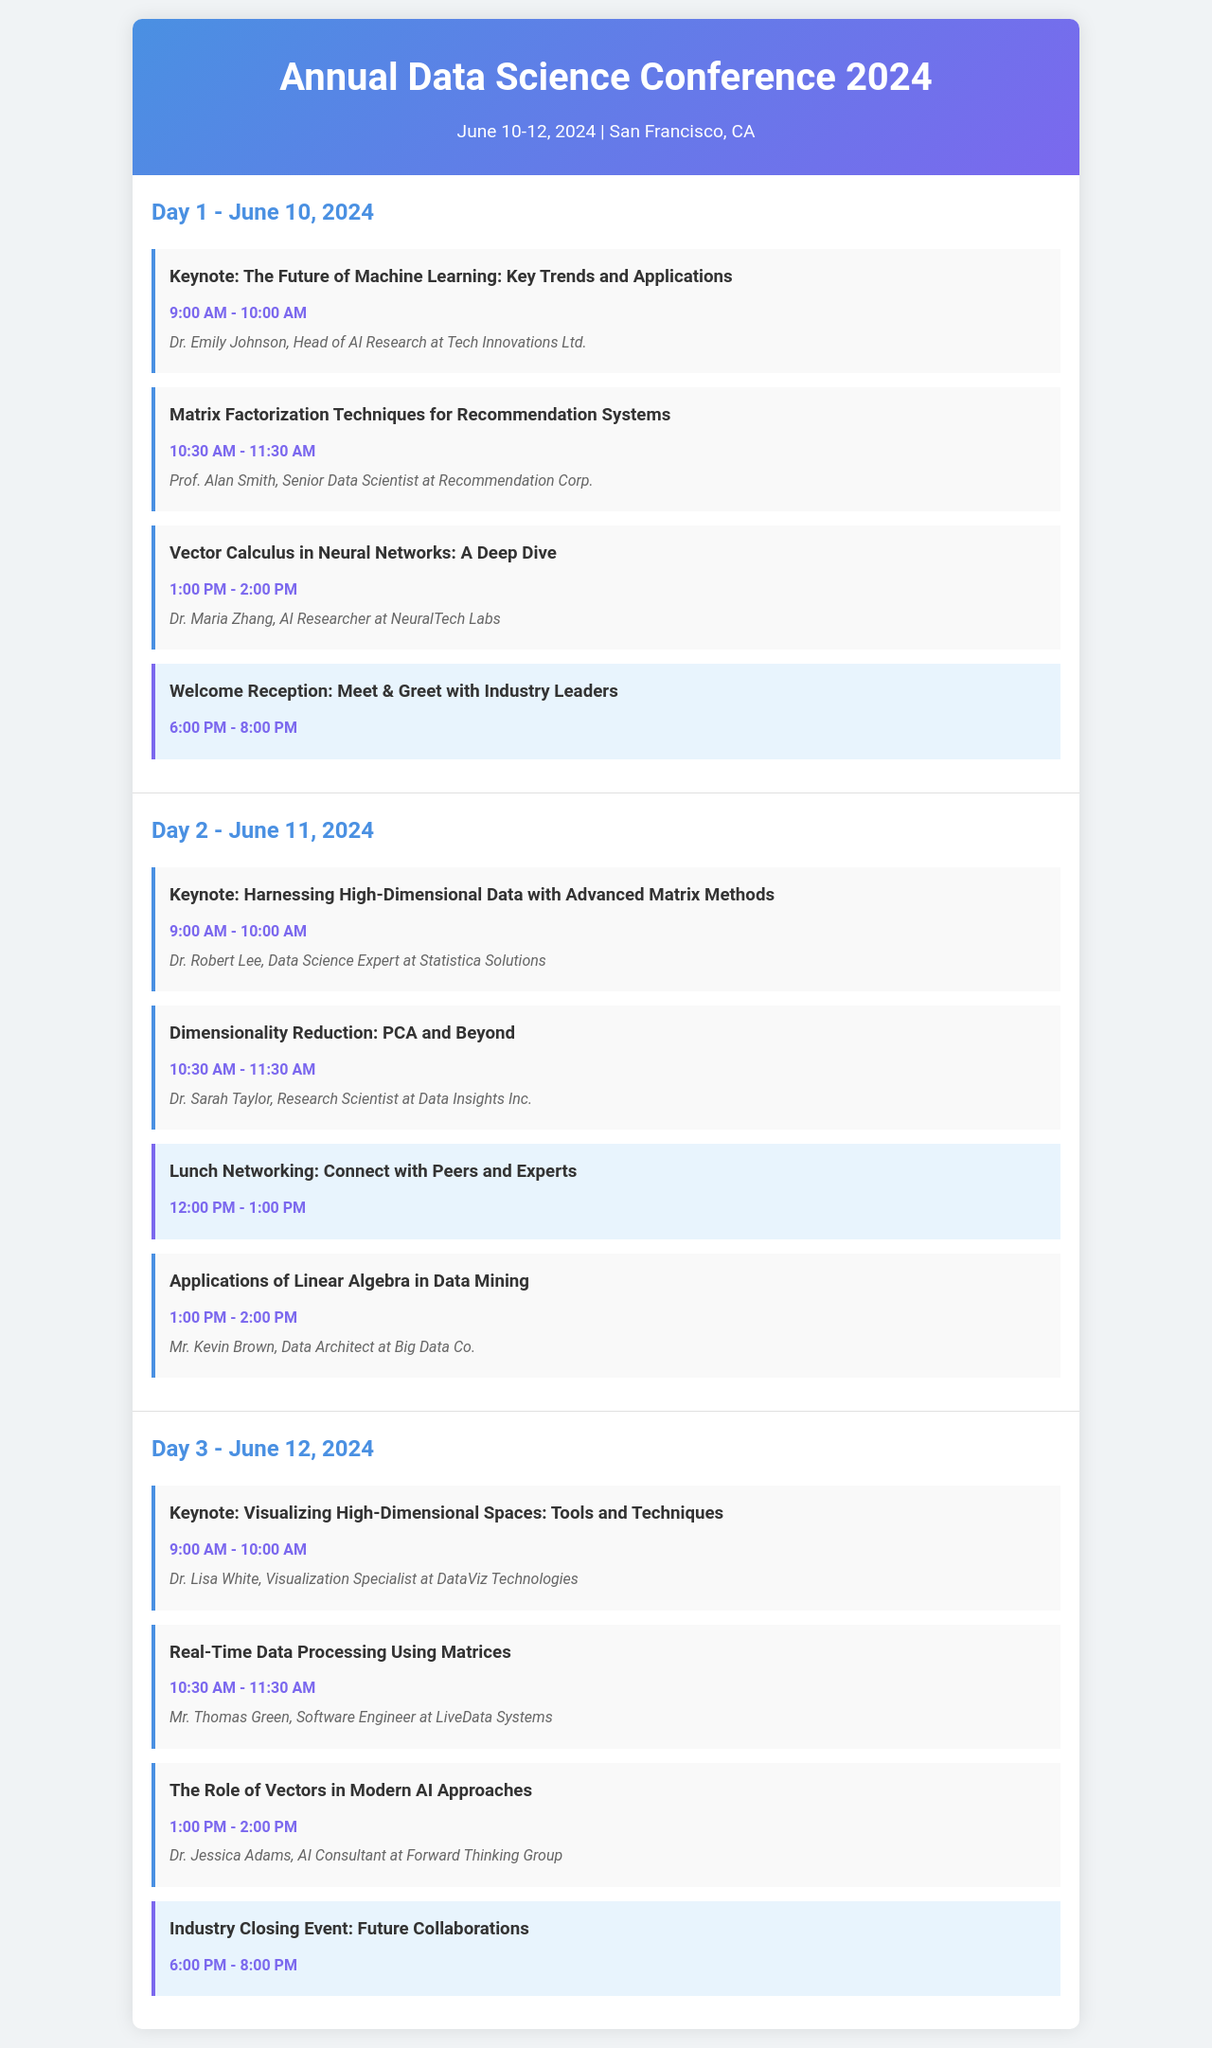What is the date of the conference? The date of the conference is mentioned in the header section as June 10-12, 2024.
Answer: June 10-12, 2024 Who is the keynote speaker on Day 2? The document lists the keynote speaker for Day 2, which is Dr. Robert Lee.
Answer: Dr. Robert Lee What time does the "Welcome Reception" start? The time for the "Welcome Reception" is specified as 6:00 PM in the schedule for Day 1.
Answer: 6:00 PM How many networking events are scheduled in the conference? By counting the occurrences in the document, there are three networking events listed throughout the schedule.
Answer: 3 Which session discusses "Applications of Linear Algebra"? The session discussing "Applications of Linear Algebra" appears on Day 2, scheduled from 1:00 PM to 2:00 PM.
Answer: Applications of Linear Algebra What is the focus of the keynote on Day 3? The keynote on Day 3 focuses on "Visualizing High-Dimensional Spaces."
Answer: Visualizing High-Dimensional Spaces What is the ending time of the last event on Day 1? The last event on Day 1, the "Welcome Reception," ends at 8:00 PM.
Answer: 8:00 PM Who is the speaker for the session on "Vector Calculus in Neural Networks"? The document identifies Dr. Maria Zhang as the speaker for this session on Day 1.
Answer: Dr. Maria Zhang 